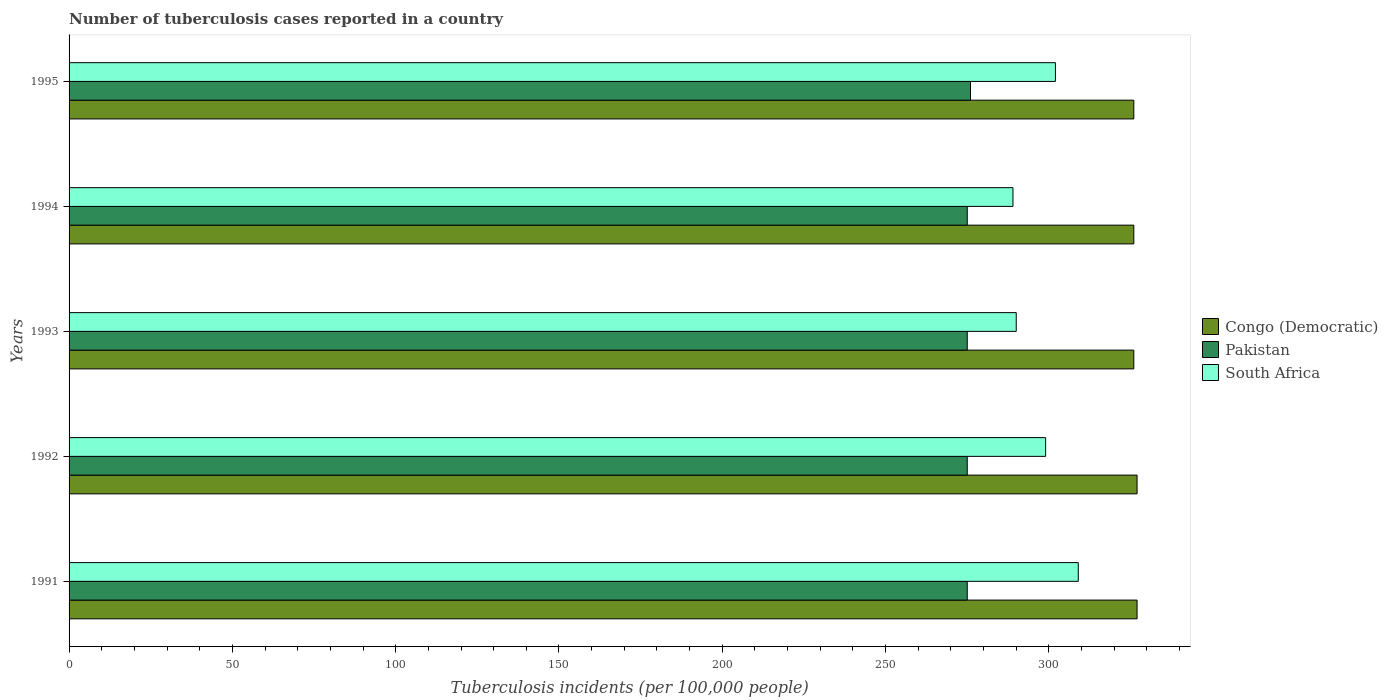How many different coloured bars are there?
Your answer should be compact. 3. Are the number of bars per tick equal to the number of legend labels?
Provide a short and direct response. Yes. How many bars are there on the 4th tick from the top?
Keep it short and to the point. 3. What is the number of tuberculosis cases reported in in Congo (Democratic) in 1995?
Make the answer very short. 326. Across all years, what is the maximum number of tuberculosis cases reported in in South Africa?
Provide a succinct answer. 309. Across all years, what is the minimum number of tuberculosis cases reported in in Pakistan?
Offer a very short reply. 275. In which year was the number of tuberculosis cases reported in in Pakistan maximum?
Your response must be concise. 1995. What is the total number of tuberculosis cases reported in in South Africa in the graph?
Offer a very short reply. 1489. What is the difference between the number of tuberculosis cases reported in in Pakistan in 1992 and that in 1993?
Keep it short and to the point. 0. What is the difference between the number of tuberculosis cases reported in in Pakistan in 1993 and the number of tuberculosis cases reported in in Congo (Democratic) in 1991?
Your response must be concise. -52. What is the average number of tuberculosis cases reported in in South Africa per year?
Offer a terse response. 297.8. In the year 1995, what is the difference between the number of tuberculosis cases reported in in South Africa and number of tuberculosis cases reported in in Pakistan?
Ensure brevity in your answer.  26. What is the ratio of the number of tuberculosis cases reported in in South Africa in 1992 to that in 1994?
Provide a succinct answer. 1.03. Is the difference between the number of tuberculosis cases reported in in South Africa in 1994 and 1995 greater than the difference between the number of tuberculosis cases reported in in Pakistan in 1994 and 1995?
Offer a very short reply. No. What is the difference between the highest and the second highest number of tuberculosis cases reported in in Congo (Democratic)?
Offer a terse response. 0. What is the difference between the highest and the lowest number of tuberculosis cases reported in in Congo (Democratic)?
Keep it short and to the point. 1. In how many years, is the number of tuberculosis cases reported in in Pakistan greater than the average number of tuberculosis cases reported in in Pakistan taken over all years?
Your response must be concise. 1. What does the 1st bar from the top in 1993 represents?
Ensure brevity in your answer.  South Africa. Are all the bars in the graph horizontal?
Give a very brief answer. Yes. Are the values on the major ticks of X-axis written in scientific E-notation?
Your answer should be very brief. No. Does the graph contain any zero values?
Provide a succinct answer. No. Does the graph contain grids?
Your answer should be compact. No. Where does the legend appear in the graph?
Make the answer very short. Center right. How many legend labels are there?
Offer a terse response. 3. How are the legend labels stacked?
Offer a very short reply. Vertical. What is the title of the graph?
Ensure brevity in your answer.  Number of tuberculosis cases reported in a country. Does "Paraguay" appear as one of the legend labels in the graph?
Your answer should be compact. No. What is the label or title of the X-axis?
Make the answer very short. Tuberculosis incidents (per 100,0 people). What is the Tuberculosis incidents (per 100,000 people) of Congo (Democratic) in 1991?
Your answer should be very brief. 327. What is the Tuberculosis incidents (per 100,000 people) of Pakistan in 1991?
Offer a terse response. 275. What is the Tuberculosis incidents (per 100,000 people) in South Africa in 1991?
Give a very brief answer. 309. What is the Tuberculosis incidents (per 100,000 people) in Congo (Democratic) in 1992?
Offer a very short reply. 327. What is the Tuberculosis incidents (per 100,000 people) in Pakistan in 1992?
Ensure brevity in your answer.  275. What is the Tuberculosis incidents (per 100,000 people) of South Africa in 1992?
Ensure brevity in your answer.  299. What is the Tuberculosis incidents (per 100,000 people) in Congo (Democratic) in 1993?
Ensure brevity in your answer.  326. What is the Tuberculosis incidents (per 100,000 people) of Pakistan in 1993?
Your response must be concise. 275. What is the Tuberculosis incidents (per 100,000 people) in South Africa in 1993?
Keep it short and to the point. 290. What is the Tuberculosis incidents (per 100,000 people) in Congo (Democratic) in 1994?
Your response must be concise. 326. What is the Tuberculosis incidents (per 100,000 people) of Pakistan in 1994?
Your answer should be compact. 275. What is the Tuberculosis incidents (per 100,000 people) in South Africa in 1994?
Keep it short and to the point. 289. What is the Tuberculosis incidents (per 100,000 people) in Congo (Democratic) in 1995?
Provide a short and direct response. 326. What is the Tuberculosis incidents (per 100,000 people) in Pakistan in 1995?
Your answer should be very brief. 276. What is the Tuberculosis incidents (per 100,000 people) in South Africa in 1995?
Your response must be concise. 302. Across all years, what is the maximum Tuberculosis incidents (per 100,000 people) in Congo (Democratic)?
Your response must be concise. 327. Across all years, what is the maximum Tuberculosis incidents (per 100,000 people) in Pakistan?
Provide a succinct answer. 276. Across all years, what is the maximum Tuberculosis incidents (per 100,000 people) of South Africa?
Your answer should be very brief. 309. Across all years, what is the minimum Tuberculosis incidents (per 100,000 people) in Congo (Democratic)?
Your answer should be compact. 326. Across all years, what is the minimum Tuberculosis incidents (per 100,000 people) of Pakistan?
Keep it short and to the point. 275. Across all years, what is the minimum Tuberculosis incidents (per 100,000 people) of South Africa?
Keep it short and to the point. 289. What is the total Tuberculosis incidents (per 100,000 people) in Congo (Democratic) in the graph?
Your answer should be compact. 1632. What is the total Tuberculosis incidents (per 100,000 people) of Pakistan in the graph?
Ensure brevity in your answer.  1376. What is the total Tuberculosis incidents (per 100,000 people) of South Africa in the graph?
Your answer should be compact. 1489. What is the difference between the Tuberculosis incidents (per 100,000 people) of Congo (Democratic) in 1991 and that in 1992?
Give a very brief answer. 0. What is the difference between the Tuberculosis incidents (per 100,000 people) in Congo (Democratic) in 1991 and that in 1993?
Your answer should be compact. 1. What is the difference between the Tuberculosis incidents (per 100,000 people) in Pakistan in 1991 and that in 1995?
Your answer should be compact. -1. What is the difference between the Tuberculosis incidents (per 100,000 people) in Congo (Democratic) in 1992 and that in 1993?
Keep it short and to the point. 1. What is the difference between the Tuberculosis incidents (per 100,000 people) of South Africa in 1992 and that in 1993?
Your answer should be very brief. 9. What is the difference between the Tuberculosis incidents (per 100,000 people) of South Africa in 1992 and that in 1994?
Ensure brevity in your answer.  10. What is the difference between the Tuberculosis incidents (per 100,000 people) of Congo (Democratic) in 1992 and that in 1995?
Your answer should be compact. 1. What is the difference between the Tuberculosis incidents (per 100,000 people) of South Africa in 1992 and that in 1995?
Offer a very short reply. -3. What is the difference between the Tuberculosis incidents (per 100,000 people) of Congo (Democratic) in 1993 and that in 1994?
Provide a succinct answer. 0. What is the difference between the Tuberculosis incidents (per 100,000 people) in South Africa in 1993 and that in 1994?
Keep it short and to the point. 1. What is the difference between the Tuberculosis incidents (per 100,000 people) in Pakistan in 1993 and that in 1995?
Give a very brief answer. -1. What is the difference between the Tuberculosis incidents (per 100,000 people) of South Africa in 1993 and that in 1995?
Your response must be concise. -12. What is the difference between the Tuberculosis incidents (per 100,000 people) of Congo (Democratic) in 1994 and that in 1995?
Your answer should be compact. 0. What is the difference between the Tuberculosis incidents (per 100,000 people) in South Africa in 1994 and that in 1995?
Provide a short and direct response. -13. What is the difference between the Tuberculosis incidents (per 100,000 people) of Congo (Democratic) in 1991 and the Tuberculosis incidents (per 100,000 people) of Pakistan in 1992?
Offer a terse response. 52. What is the difference between the Tuberculosis incidents (per 100,000 people) in Congo (Democratic) in 1991 and the Tuberculosis incidents (per 100,000 people) in South Africa in 1992?
Ensure brevity in your answer.  28. What is the difference between the Tuberculosis incidents (per 100,000 people) in Pakistan in 1991 and the Tuberculosis incidents (per 100,000 people) in South Africa in 1992?
Provide a succinct answer. -24. What is the difference between the Tuberculosis incidents (per 100,000 people) in Pakistan in 1991 and the Tuberculosis incidents (per 100,000 people) in South Africa in 1993?
Keep it short and to the point. -15. What is the difference between the Tuberculosis incidents (per 100,000 people) of Pakistan in 1991 and the Tuberculosis incidents (per 100,000 people) of South Africa in 1994?
Your answer should be very brief. -14. What is the difference between the Tuberculosis incidents (per 100,000 people) in Congo (Democratic) in 1991 and the Tuberculosis incidents (per 100,000 people) in Pakistan in 1995?
Make the answer very short. 51. What is the difference between the Tuberculosis incidents (per 100,000 people) of Congo (Democratic) in 1992 and the Tuberculosis incidents (per 100,000 people) of Pakistan in 1994?
Your response must be concise. 52. What is the difference between the Tuberculosis incidents (per 100,000 people) of Pakistan in 1992 and the Tuberculosis incidents (per 100,000 people) of South Africa in 1994?
Give a very brief answer. -14. What is the difference between the Tuberculosis incidents (per 100,000 people) of Congo (Democratic) in 1992 and the Tuberculosis incidents (per 100,000 people) of Pakistan in 1995?
Offer a terse response. 51. What is the difference between the Tuberculosis incidents (per 100,000 people) of Congo (Democratic) in 1992 and the Tuberculosis incidents (per 100,000 people) of South Africa in 1995?
Your response must be concise. 25. What is the difference between the Tuberculosis incidents (per 100,000 people) of Congo (Democratic) in 1993 and the Tuberculosis incidents (per 100,000 people) of South Africa in 1994?
Keep it short and to the point. 37. What is the difference between the Tuberculosis incidents (per 100,000 people) in Congo (Democratic) in 1993 and the Tuberculosis incidents (per 100,000 people) in Pakistan in 1995?
Offer a terse response. 50. What is the difference between the Tuberculosis incidents (per 100,000 people) of Congo (Democratic) in 1994 and the Tuberculosis incidents (per 100,000 people) of Pakistan in 1995?
Provide a succinct answer. 50. What is the difference between the Tuberculosis incidents (per 100,000 people) of Congo (Democratic) in 1994 and the Tuberculosis incidents (per 100,000 people) of South Africa in 1995?
Ensure brevity in your answer.  24. What is the average Tuberculosis incidents (per 100,000 people) in Congo (Democratic) per year?
Offer a terse response. 326.4. What is the average Tuberculosis incidents (per 100,000 people) of Pakistan per year?
Offer a very short reply. 275.2. What is the average Tuberculosis incidents (per 100,000 people) of South Africa per year?
Provide a succinct answer. 297.8. In the year 1991, what is the difference between the Tuberculosis incidents (per 100,000 people) of Congo (Democratic) and Tuberculosis incidents (per 100,000 people) of South Africa?
Provide a short and direct response. 18. In the year 1991, what is the difference between the Tuberculosis incidents (per 100,000 people) of Pakistan and Tuberculosis incidents (per 100,000 people) of South Africa?
Provide a short and direct response. -34. In the year 1992, what is the difference between the Tuberculosis incidents (per 100,000 people) in Congo (Democratic) and Tuberculosis incidents (per 100,000 people) in Pakistan?
Your answer should be compact. 52. In the year 1993, what is the difference between the Tuberculosis incidents (per 100,000 people) in Congo (Democratic) and Tuberculosis incidents (per 100,000 people) in Pakistan?
Provide a succinct answer. 51. In the year 1993, what is the difference between the Tuberculosis incidents (per 100,000 people) in Congo (Democratic) and Tuberculosis incidents (per 100,000 people) in South Africa?
Make the answer very short. 36. In the year 1993, what is the difference between the Tuberculosis incidents (per 100,000 people) of Pakistan and Tuberculosis incidents (per 100,000 people) of South Africa?
Provide a short and direct response. -15. In the year 1994, what is the difference between the Tuberculosis incidents (per 100,000 people) of Congo (Democratic) and Tuberculosis incidents (per 100,000 people) of Pakistan?
Provide a short and direct response. 51. In the year 1995, what is the difference between the Tuberculosis incidents (per 100,000 people) in Congo (Democratic) and Tuberculosis incidents (per 100,000 people) in Pakistan?
Give a very brief answer. 50. What is the ratio of the Tuberculosis incidents (per 100,000 people) in South Africa in 1991 to that in 1992?
Keep it short and to the point. 1.03. What is the ratio of the Tuberculosis incidents (per 100,000 people) of Congo (Democratic) in 1991 to that in 1993?
Offer a terse response. 1. What is the ratio of the Tuberculosis incidents (per 100,000 people) in South Africa in 1991 to that in 1993?
Provide a succinct answer. 1.07. What is the ratio of the Tuberculosis incidents (per 100,000 people) in Congo (Democratic) in 1991 to that in 1994?
Ensure brevity in your answer.  1. What is the ratio of the Tuberculosis incidents (per 100,000 people) in South Africa in 1991 to that in 1994?
Provide a succinct answer. 1.07. What is the ratio of the Tuberculosis incidents (per 100,000 people) in Congo (Democratic) in 1991 to that in 1995?
Your response must be concise. 1. What is the ratio of the Tuberculosis incidents (per 100,000 people) in South Africa in 1991 to that in 1995?
Your answer should be very brief. 1.02. What is the ratio of the Tuberculosis incidents (per 100,000 people) of Pakistan in 1992 to that in 1993?
Give a very brief answer. 1. What is the ratio of the Tuberculosis incidents (per 100,000 people) of South Africa in 1992 to that in 1993?
Your answer should be very brief. 1.03. What is the ratio of the Tuberculosis incidents (per 100,000 people) of Congo (Democratic) in 1992 to that in 1994?
Your response must be concise. 1. What is the ratio of the Tuberculosis incidents (per 100,000 people) of South Africa in 1992 to that in 1994?
Offer a terse response. 1.03. What is the ratio of the Tuberculosis incidents (per 100,000 people) of Congo (Democratic) in 1992 to that in 1995?
Ensure brevity in your answer.  1. What is the ratio of the Tuberculosis incidents (per 100,000 people) of South Africa in 1992 to that in 1995?
Provide a succinct answer. 0.99. What is the ratio of the Tuberculosis incidents (per 100,000 people) of South Africa in 1993 to that in 1994?
Your answer should be compact. 1. What is the ratio of the Tuberculosis incidents (per 100,000 people) of Congo (Democratic) in 1993 to that in 1995?
Your answer should be very brief. 1. What is the ratio of the Tuberculosis incidents (per 100,000 people) in Pakistan in 1993 to that in 1995?
Provide a short and direct response. 1. What is the ratio of the Tuberculosis incidents (per 100,000 people) of South Africa in 1993 to that in 1995?
Provide a short and direct response. 0.96. What is the ratio of the Tuberculosis incidents (per 100,000 people) in Congo (Democratic) in 1994 to that in 1995?
Your response must be concise. 1. What is the ratio of the Tuberculosis incidents (per 100,000 people) in Pakistan in 1994 to that in 1995?
Ensure brevity in your answer.  1. What is the ratio of the Tuberculosis incidents (per 100,000 people) in South Africa in 1994 to that in 1995?
Your answer should be compact. 0.96. What is the difference between the highest and the second highest Tuberculosis incidents (per 100,000 people) of Congo (Democratic)?
Provide a succinct answer. 0. What is the difference between the highest and the second highest Tuberculosis incidents (per 100,000 people) of Pakistan?
Offer a terse response. 1. What is the difference between the highest and the second highest Tuberculosis incidents (per 100,000 people) in South Africa?
Offer a terse response. 7. What is the difference between the highest and the lowest Tuberculosis incidents (per 100,000 people) of Pakistan?
Offer a terse response. 1. 